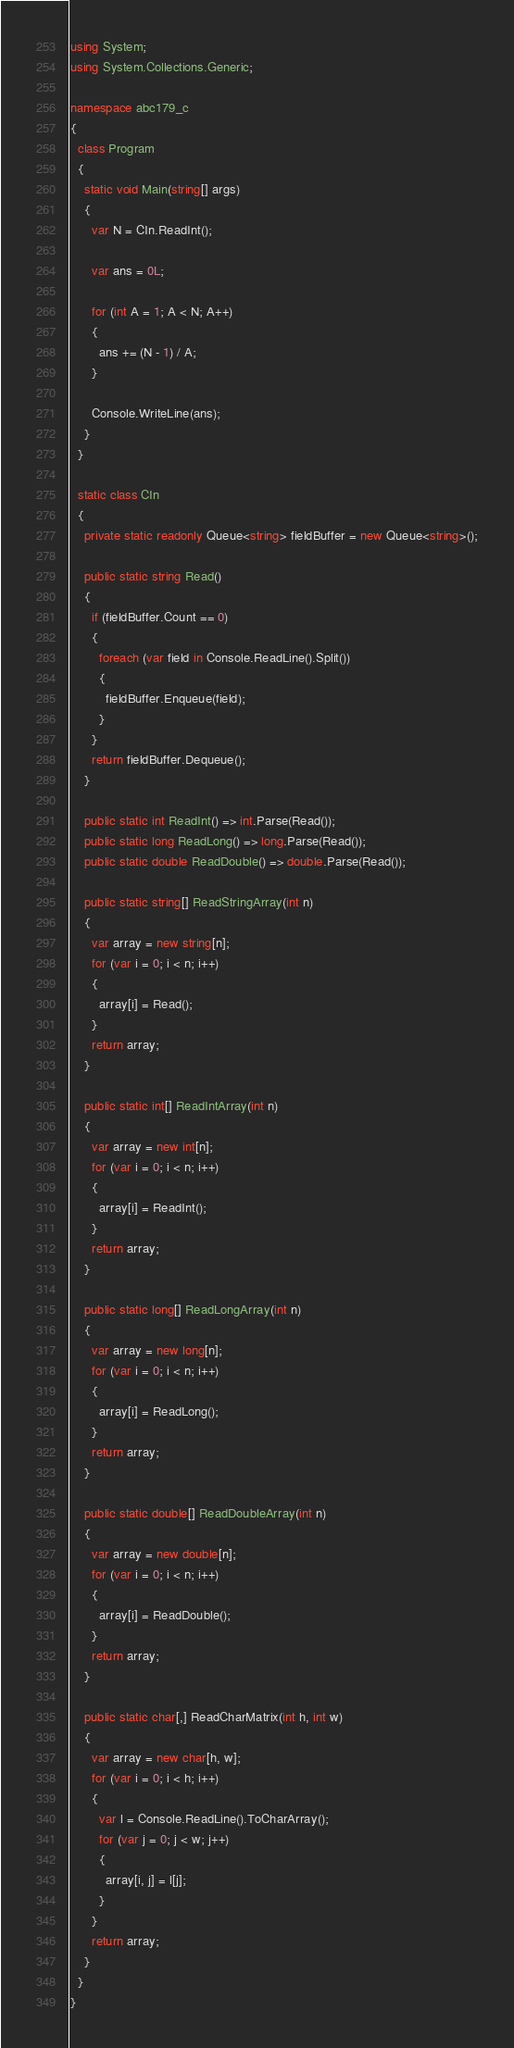<code> <loc_0><loc_0><loc_500><loc_500><_C#_>using System;
using System.Collections.Generic;

namespace abc179_c
{
  class Program
  {
    static void Main(string[] args)
    {
      var N = CIn.ReadInt();

      var ans = 0L;

      for (int A = 1; A < N; A++)
      {
        ans += (N - 1) / A;
      }

      Console.WriteLine(ans);
    }
  }

  static class CIn
  {
    private static readonly Queue<string> fieldBuffer = new Queue<string>();

    public static string Read()
    {
      if (fieldBuffer.Count == 0)
      {
        foreach (var field in Console.ReadLine().Split())
        {
          fieldBuffer.Enqueue(field);
        }
      }
      return fieldBuffer.Dequeue();
    }

    public static int ReadInt() => int.Parse(Read());
    public static long ReadLong() => long.Parse(Read());
    public static double ReadDouble() => double.Parse(Read());

    public static string[] ReadStringArray(int n)
    {
      var array = new string[n];
      for (var i = 0; i < n; i++)
      {
        array[i] = Read();
      }
      return array;
    }

    public static int[] ReadIntArray(int n)
    {
      var array = new int[n];
      for (var i = 0; i < n; i++)
      {
        array[i] = ReadInt();
      }
      return array;
    }

    public static long[] ReadLongArray(int n)
    {
      var array = new long[n];
      for (var i = 0; i < n; i++)
      {
        array[i] = ReadLong();
      }
      return array;
    }

    public static double[] ReadDoubleArray(int n)
    {
      var array = new double[n];
      for (var i = 0; i < n; i++)
      {
        array[i] = ReadDouble();
      }
      return array;
    }

    public static char[,] ReadCharMatrix(int h, int w)
    {
      var array = new char[h, w];
      for (var i = 0; i < h; i++)
      {
        var l = Console.ReadLine().ToCharArray();
        for (var j = 0; j < w; j++)
        {
          array[i, j] = l[j];
        }
      }
      return array;
    }
  }
}
</code> 